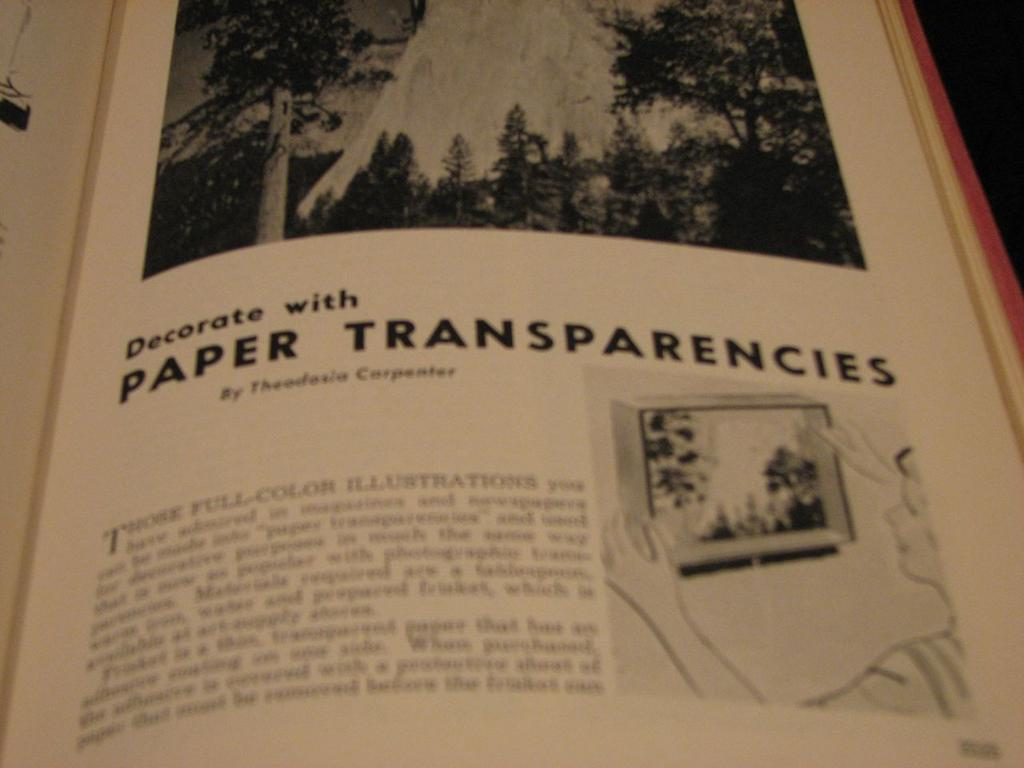<image>
Create a compact narrative representing the image presented. The title of the chapter is Decorate with Paper Transparencies. 